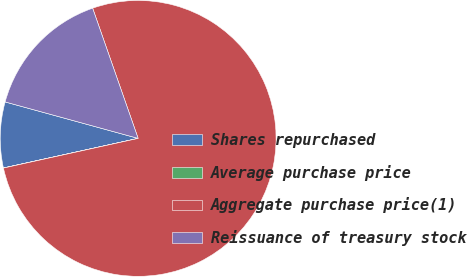<chart> <loc_0><loc_0><loc_500><loc_500><pie_chart><fcel>Shares repurchased<fcel>Average purchase price<fcel>Aggregate purchase price(1)<fcel>Reissuance of treasury stock<nl><fcel>7.7%<fcel>0.01%<fcel>76.9%<fcel>15.39%<nl></chart> 